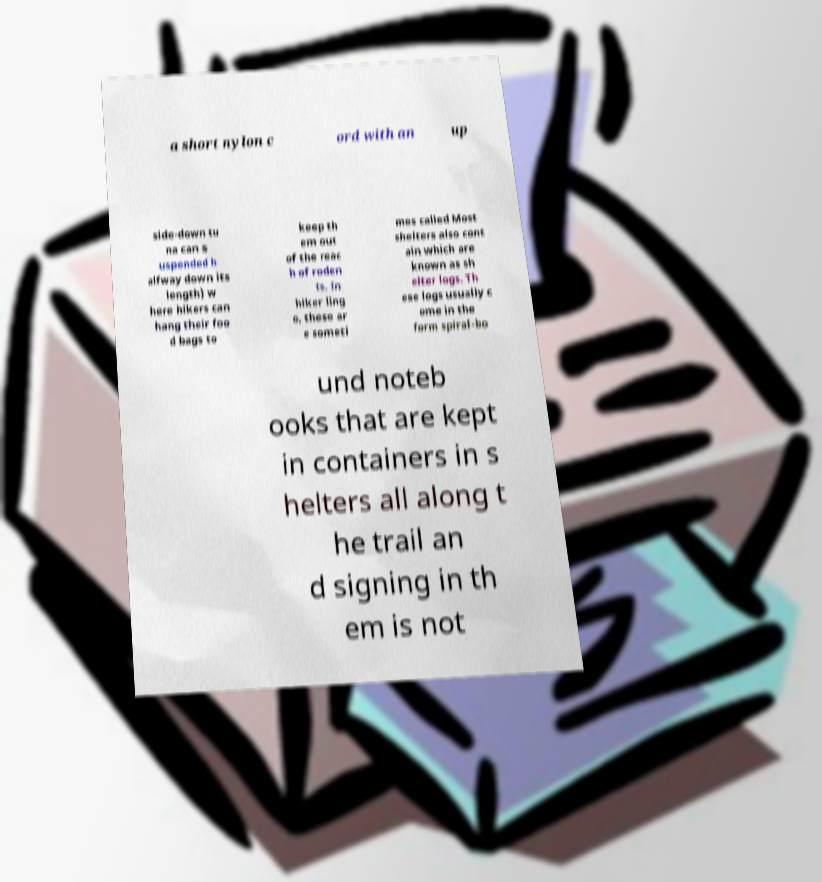Can you accurately transcribe the text from the provided image for me? a short nylon c ord with an up side-down tu na can s uspended h alfway down its length) w here hikers can hang their foo d bags to keep th em out of the reac h of roden ts. In hiker ling o, these ar e someti mes called Most shelters also cont ain which are known as sh elter logs. Th ese logs usually c ome in the form spiral-bo und noteb ooks that are kept in containers in s helters all along t he trail an d signing in th em is not 